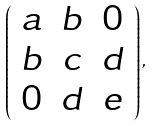<formula> <loc_0><loc_0><loc_500><loc_500>\left ( \begin{array} { c c c } { a } & { b } & { 0 } \\ { b } & { c } & { d } \\ { 0 } & { d } & { e } \end{array} \right ) ,</formula> 